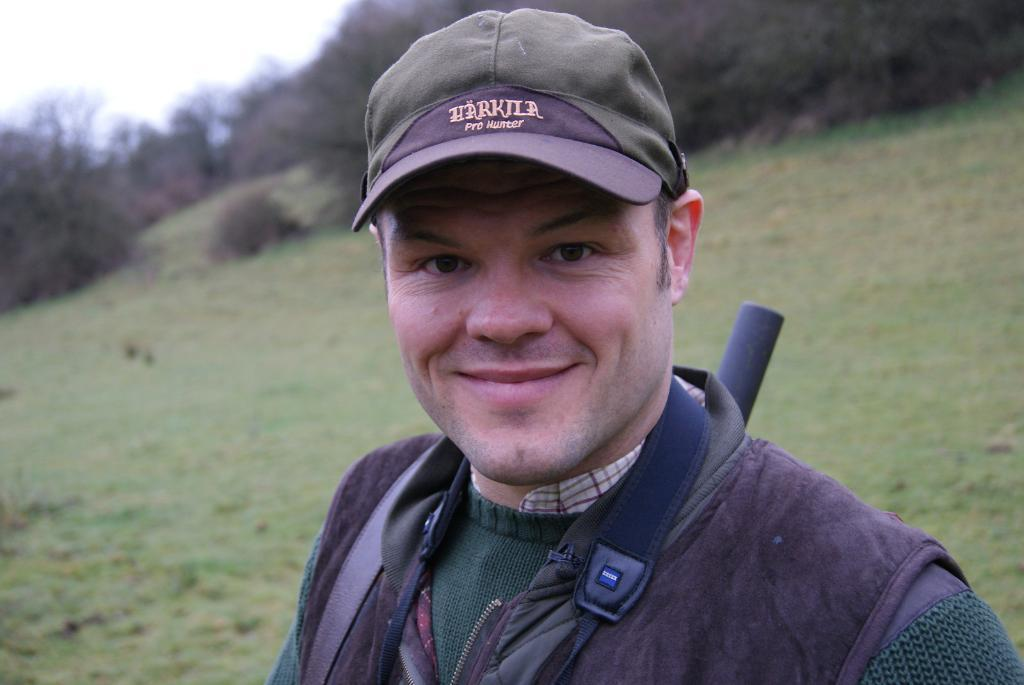Who is the main subject in the image? There is a man in the image. What is the man wearing on his upper body? The man is wearing a sweatshirt. What is the man wearing on his head? The man is wearing a cap. Where is the man positioned in the image? The man is standing in the front of the image. What type of vegetation covers the land behind the man? The land behind the man is covered with grass. Are there any trees visible on the land? Yes, trees are present on the land. What type of spacecraft can be seen in the image? There is no spacecraft present in the image; it features a man standing in front of a grassy land with trees. What emotion does the man express towards the trees in the image? The image does not convey any specific emotions, and there is no indication of the man's feelings towards the trees. 